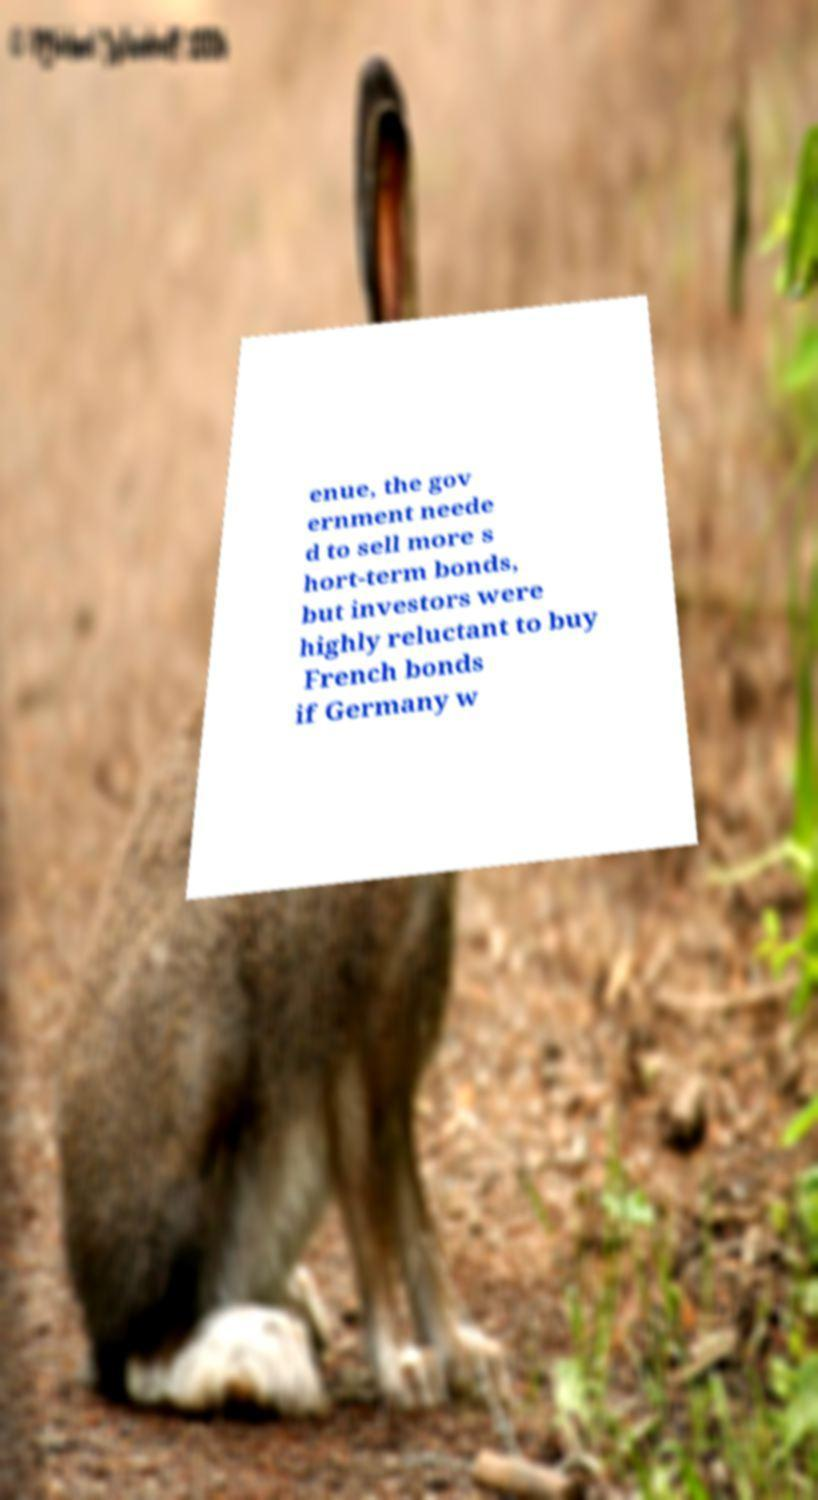Can you accurately transcribe the text from the provided image for me? enue, the gov ernment neede d to sell more s hort-term bonds, but investors were highly reluctant to buy French bonds if Germany w 